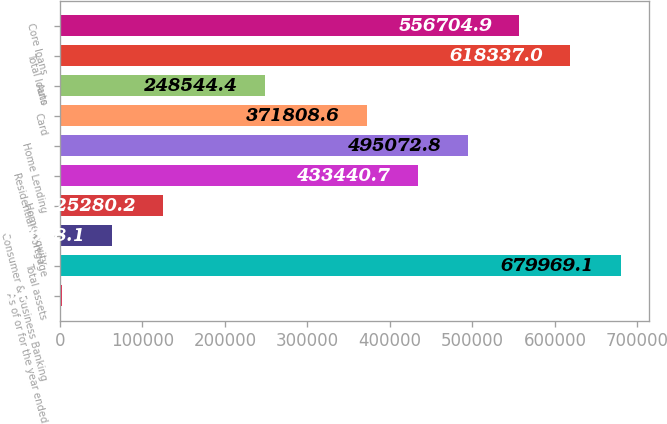<chart> <loc_0><loc_0><loc_500><loc_500><bar_chart><fcel>As of or for the year ended<fcel>Total assets<fcel>Consumer & Business Banking<fcel>Home equity<fcel>Residential mortgage<fcel>Home Lending<fcel>Card<fcel>Auto<fcel>Total loans<fcel>Core loans<nl><fcel>2016<fcel>679969<fcel>63648.1<fcel>125280<fcel>433441<fcel>495073<fcel>371809<fcel>248544<fcel>618337<fcel>556705<nl></chart> 